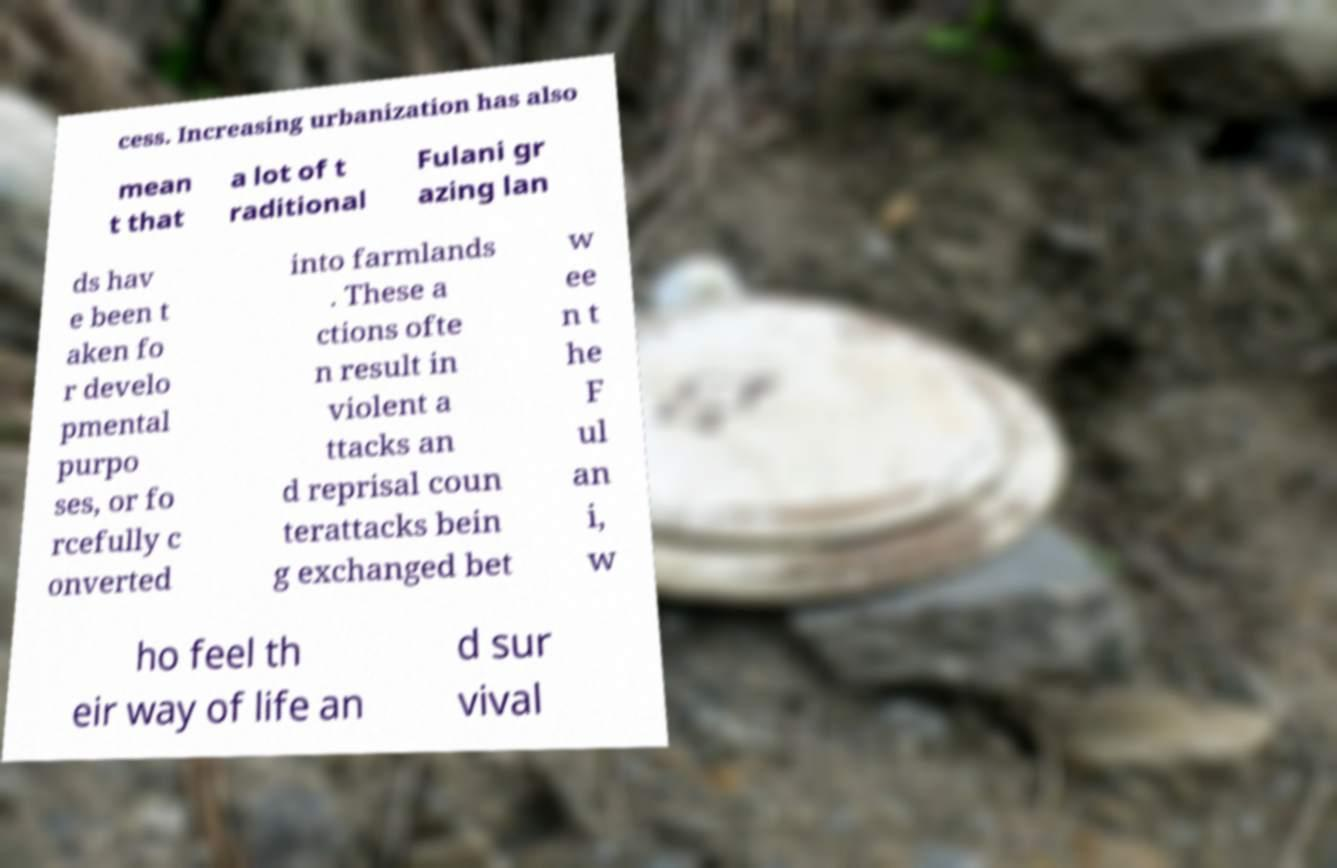I need the written content from this picture converted into text. Can you do that? cess. Increasing urbanization has also mean t that a lot of t raditional Fulani gr azing lan ds hav e been t aken fo r develo pmental purpo ses, or fo rcefully c onverted into farmlands . These a ctions ofte n result in violent a ttacks an d reprisal coun terattacks bein g exchanged bet w ee n t he F ul an i, w ho feel th eir way of life an d sur vival 